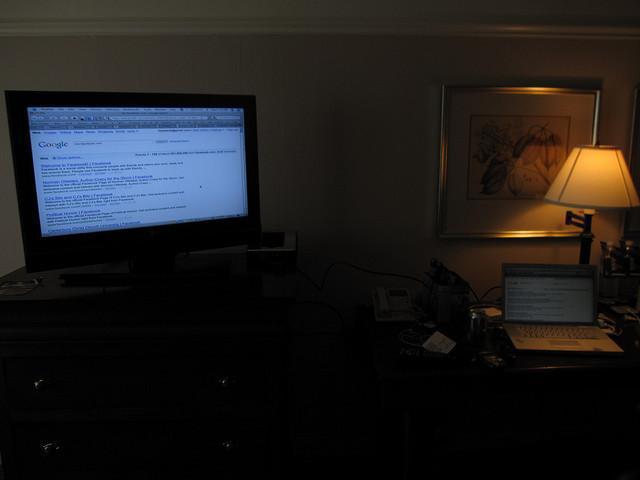How many men are carrying a leather briefcase?
Give a very brief answer. 0. 